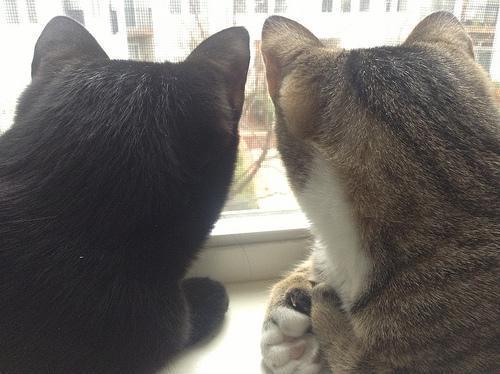How many cats are there?
Give a very brief answer. 2. 